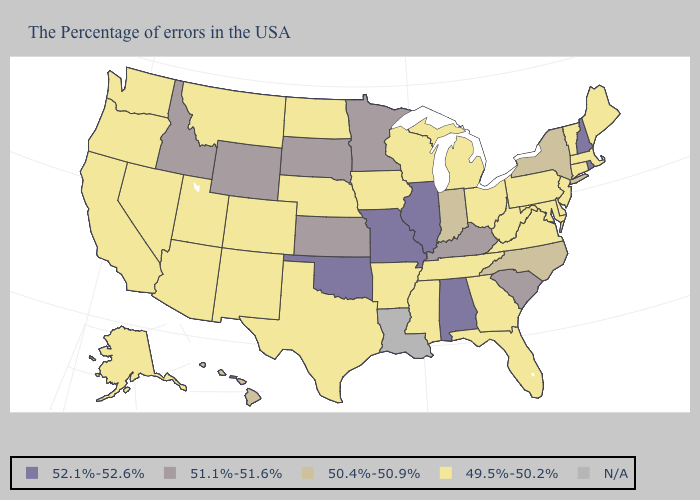Name the states that have a value in the range N/A?
Short answer required. Louisiana. What is the lowest value in the USA?
Be succinct. 49.5%-50.2%. What is the highest value in the USA?
Answer briefly. 52.1%-52.6%. How many symbols are there in the legend?
Keep it brief. 5. Which states have the highest value in the USA?
Keep it brief. Rhode Island, New Hampshire, Alabama, Illinois, Missouri, Oklahoma. Does the first symbol in the legend represent the smallest category?
Short answer required. No. What is the lowest value in the USA?
Keep it brief. 49.5%-50.2%. Is the legend a continuous bar?
Concise answer only. No. Does the first symbol in the legend represent the smallest category?
Answer briefly. No. What is the value of Georgia?
Be succinct. 49.5%-50.2%. Does Arkansas have the lowest value in the USA?
Write a very short answer. Yes. Name the states that have a value in the range 49.5%-50.2%?
Write a very short answer. Maine, Massachusetts, Vermont, Connecticut, New Jersey, Delaware, Maryland, Pennsylvania, Virginia, West Virginia, Ohio, Florida, Georgia, Michigan, Tennessee, Wisconsin, Mississippi, Arkansas, Iowa, Nebraska, Texas, North Dakota, Colorado, New Mexico, Utah, Montana, Arizona, Nevada, California, Washington, Oregon, Alaska. Which states have the highest value in the USA?
Short answer required. Rhode Island, New Hampshire, Alabama, Illinois, Missouri, Oklahoma. What is the highest value in states that border Vermont?
Give a very brief answer. 52.1%-52.6%. Among the states that border Michigan , does Indiana have the lowest value?
Short answer required. No. 